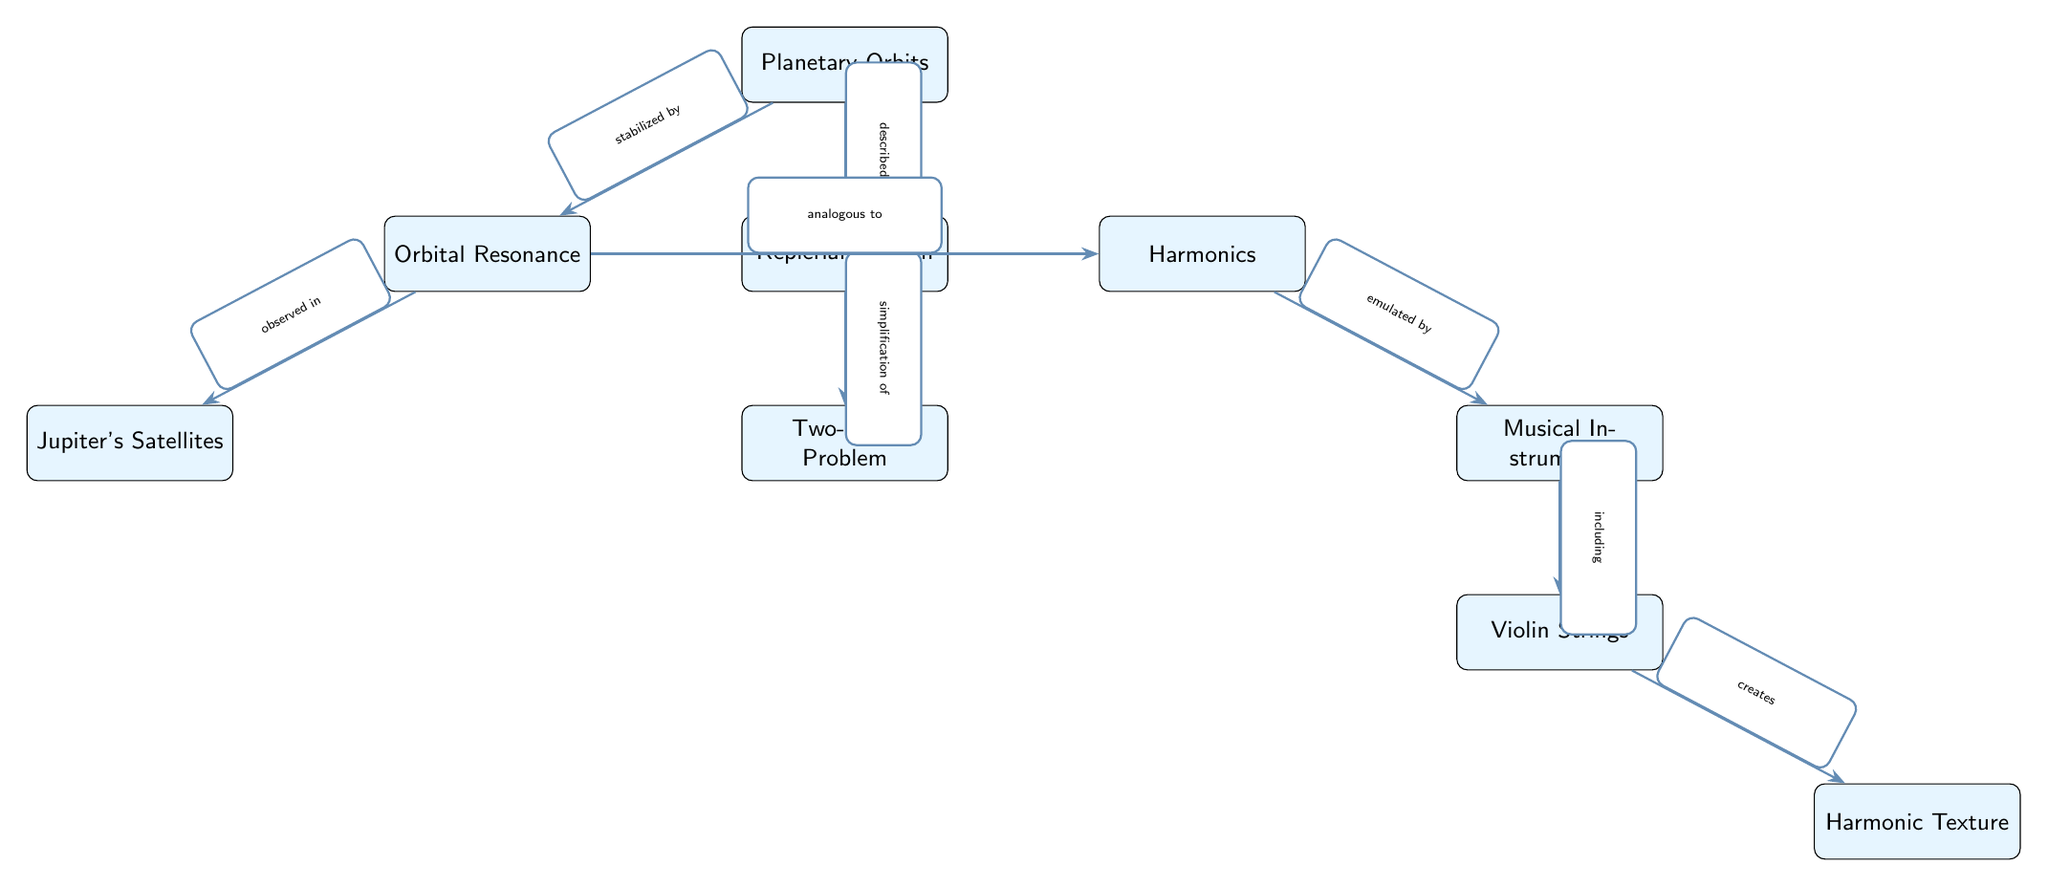What is the main subject of the diagram? The main subject of the diagram is represented by the central node labeled "Planetary Orbits." This is clearly indicated as it connects to various other concepts related to planetary motion and harmonics.
Answer: Planetary Orbits Which node is observed in relation to orbital resonance? The node "Jupiter's Satellites" is directly connected to "Orbital Resonance" with the edge labeled "observed in," indicating that this node's behaviors or characteristics are examples of orbital resonance.
Answer: Jupiter's Satellites How many main concepts are directly related to "Harmonics"? In the diagram, "Harmonics" is connected to one main concept labeled "Orbital Resonance" and another labeled "Musical Instruments." Counting these connections, we find a total of two direct associations.
Answer: 2 What relationship does "Keplerian Motion" have with the "Two-Body Problem"? The relationship is indicated by the edge connecting "Keplerian Motion" to "Two-Body Problem," with the label "simplification of," suggesting that Kepler's laws apply when considering a simplified two-body system.
Answer: simplification of Which musical component is included under "Musical Instruments"? The node "Violin Strings" is a sub-node of "Musical Instruments," explicitly labeled with "including," indicating its role as a component in this category.
Answer: Violin Strings What type of motion is described by "Keplerian Motion"? The connection of "Planetary Orbits" to "Keplerian Motion" through the edge labeled "described by" indicates that Keplerian motion pertains to the specific behaviors of planetary orbits as understood through Kepler's laws.
Answer: described by How does "Orbital Resonance" relate to "Harmonics"? The label on the connecting edge from "Orbital Resonance" to "Harmonics" is "analogous to," suggesting that there is a similarity or parallel between the concepts of orbital resonance and harmonic properties in music.
Answer: analogous to What creates "Harmonic Texture"? "Harmonic Texture" is directly connected to "Violin Strings," where the edge is labeled "creates," indicating that the properties of violin strings lead to this specific aspect of music.
Answer: creates 